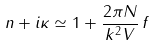<formula> <loc_0><loc_0><loc_500><loc_500>n + i \kappa \simeq 1 + \frac { 2 \pi N } { k ^ { 2 } V } \, f</formula> 